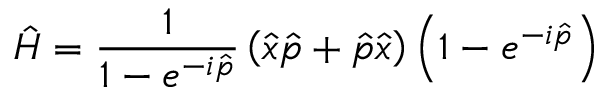<formula> <loc_0><loc_0><loc_500><loc_500>{ \hat { H } } = { \frac { 1 } { 1 - e ^ { - i { \hat { p } } } } } \left ( { \hat { x } } { \hat { p } } + { \hat { p } } { \hat { x } } \right ) \left ( 1 - e ^ { - i { \hat { p } } } \right )</formula> 